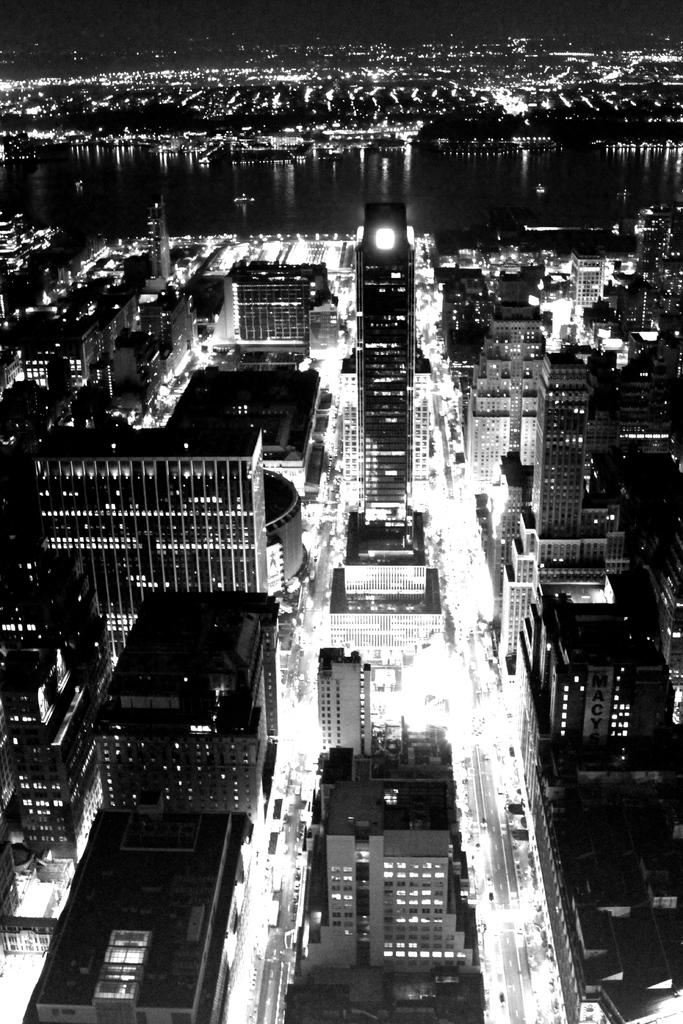What type of structures can be seen in the image? There are many buildings in the image. What can be seen illuminating the image? There are lights visible in the image. What type of natural element is visible in the image? There is some water visible in the image. What type of zinc is being used to insure the buildings in the image? There is no mention of zinc or insurance in the image; it simply shows many buildings, lights, and water. 